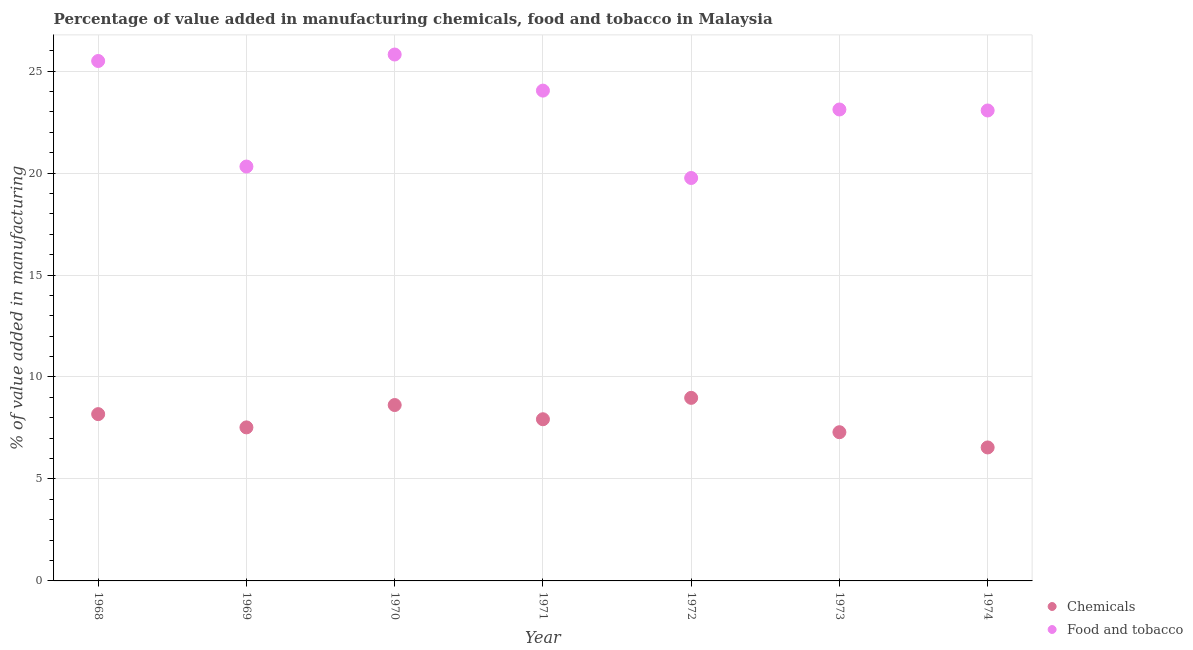Is the number of dotlines equal to the number of legend labels?
Provide a succinct answer. Yes. What is the value added by  manufacturing chemicals in 1968?
Give a very brief answer. 8.18. Across all years, what is the maximum value added by  manufacturing chemicals?
Your answer should be very brief. 8.98. Across all years, what is the minimum value added by  manufacturing chemicals?
Offer a terse response. 6.54. In which year was the value added by manufacturing food and tobacco maximum?
Offer a terse response. 1970. What is the total value added by manufacturing food and tobacco in the graph?
Keep it short and to the point. 161.61. What is the difference between the value added by manufacturing food and tobacco in 1971 and that in 1974?
Ensure brevity in your answer.  0.97. What is the difference between the value added by manufacturing food and tobacco in 1969 and the value added by  manufacturing chemicals in 1968?
Give a very brief answer. 12.14. What is the average value added by  manufacturing chemicals per year?
Provide a succinct answer. 7.87. In the year 1972, what is the difference between the value added by manufacturing food and tobacco and value added by  manufacturing chemicals?
Offer a terse response. 10.78. In how many years, is the value added by manufacturing food and tobacco greater than 25 %?
Your answer should be compact. 2. What is the ratio of the value added by manufacturing food and tobacco in 1971 to that in 1972?
Your answer should be compact. 1.22. What is the difference between the highest and the second highest value added by manufacturing food and tobacco?
Provide a succinct answer. 0.32. What is the difference between the highest and the lowest value added by manufacturing food and tobacco?
Offer a terse response. 6.05. Is the value added by manufacturing food and tobacco strictly greater than the value added by  manufacturing chemicals over the years?
Ensure brevity in your answer.  Yes. Is the value added by  manufacturing chemicals strictly less than the value added by manufacturing food and tobacco over the years?
Make the answer very short. Yes. How many dotlines are there?
Your answer should be very brief. 2. How many years are there in the graph?
Ensure brevity in your answer.  7. What is the difference between two consecutive major ticks on the Y-axis?
Make the answer very short. 5. Are the values on the major ticks of Y-axis written in scientific E-notation?
Your answer should be very brief. No. What is the title of the graph?
Your response must be concise. Percentage of value added in manufacturing chemicals, food and tobacco in Malaysia. What is the label or title of the Y-axis?
Provide a short and direct response. % of value added in manufacturing. What is the % of value added in manufacturing in Chemicals in 1968?
Make the answer very short. 8.18. What is the % of value added in manufacturing of Food and tobacco in 1968?
Offer a terse response. 25.49. What is the % of value added in manufacturing in Chemicals in 1969?
Ensure brevity in your answer.  7.53. What is the % of value added in manufacturing of Food and tobacco in 1969?
Your answer should be very brief. 20.32. What is the % of value added in manufacturing in Chemicals in 1970?
Offer a very short reply. 8.62. What is the % of value added in manufacturing in Food and tobacco in 1970?
Make the answer very short. 25.81. What is the % of value added in manufacturing in Chemicals in 1971?
Provide a succinct answer. 7.93. What is the % of value added in manufacturing of Food and tobacco in 1971?
Make the answer very short. 24.04. What is the % of value added in manufacturing in Chemicals in 1972?
Give a very brief answer. 8.98. What is the % of value added in manufacturing of Food and tobacco in 1972?
Provide a succinct answer. 19.76. What is the % of value added in manufacturing in Chemicals in 1973?
Ensure brevity in your answer.  7.29. What is the % of value added in manufacturing in Food and tobacco in 1973?
Your answer should be compact. 23.12. What is the % of value added in manufacturing in Chemicals in 1974?
Ensure brevity in your answer.  6.54. What is the % of value added in manufacturing in Food and tobacco in 1974?
Keep it short and to the point. 23.07. Across all years, what is the maximum % of value added in manufacturing of Chemicals?
Your answer should be very brief. 8.98. Across all years, what is the maximum % of value added in manufacturing in Food and tobacco?
Provide a succinct answer. 25.81. Across all years, what is the minimum % of value added in manufacturing in Chemicals?
Your answer should be very brief. 6.54. Across all years, what is the minimum % of value added in manufacturing in Food and tobacco?
Offer a terse response. 19.76. What is the total % of value added in manufacturing in Chemicals in the graph?
Make the answer very short. 55.07. What is the total % of value added in manufacturing in Food and tobacco in the graph?
Offer a very short reply. 161.61. What is the difference between the % of value added in manufacturing of Chemicals in 1968 and that in 1969?
Offer a very short reply. 0.65. What is the difference between the % of value added in manufacturing in Food and tobacco in 1968 and that in 1969?
Offer a terse response. 5.18. What is the difference between the % of value added in manufacturing of Chemicals in 1968 and that in 1970?
Your answer should be very brief. -0.45. What is the difference between the % of value added in manufacturing of Food and tobacco in 1968 and that in 1970?
Your response must be concise. -0.32. What is the difference between the % of value added in manufacturing in Chemicals in 1968 and that in 1971?
Offer a terse response. 0.25. What is the difference between the % of value added in manufacturing of Food and tobacco in 1968 and that in 1971?
Provide a succinct answer. 1.45. What is the difference between the % of value added in manufacturing in Chemicals in 1968 and that in 1972?
Offer a very short reply. -0.8. What is the difference between the % of value added in manufacturing of Food and tobacco in 1968 and that in 1972?
Your answer should be very brief. 5.74. What is the difference between the % of value added in manufacturing of Chemicals in 1968 and that in 1973?
Give a very brief answer. 0.89. What is the difference between the % of value added in manufacturing in Food and tobacco in 1968 and that in 1973?
Your response must be concise. 2.38. What is the difference between the % of value added in manufacturing in Chemicals in 1968 and that in 1974?
Make the answer very short. 1.63. What is the difference between the % of value added in manufacturing of Food and tobacco in 1968 and that in 1974?
Provide a succinct answer. 2.43. What is the difference between the % of value added in manufacturing in Chemicals in 1969 and that in 1970?
Give a very brief answer. -1.1. What is the difference between the % of value added in manufacturing in Food and tobacco in 1969 and that in 1970?
Provide a short and direct response. -5.49. What is the difference between the % of value added in manufacturing in Chemicals in 1969 and that in 1971?
Offer a very short reply. -0.4. What is the difference between the % of value added in manufacturing in Food and tobacco in 1969 and that in 1971?
Make the answer very short. -3.72. What is the difference between the % of value added in manufacturing of Chemicals in 1969 and that in 1972?
Offer a very short reply. -1.45. What is the difference between the % of value added in manufacturing of Food and tobacco in 1969 and that in 1972?
Offer a terse response. 0.56. What is the difference between the % of value added in manufacturing of Chemicals in 1969 and that in 1973?
Your response must be concise. 0.24. What is the difference between the % of value added in manufacturing of Food and tobacco in 1969 and that in 1973?
Give a very brief answer. -2.8. What is the difference between the % of value added in manufacturing of Chemicals in 1969 and that in 1974?
Make the answer very short. 0.98. What is the difference between the % of value added in manufacturing in Food and tobacco in 1969 and that in 1974?
Your response must be concise. -2.75. What is the difference between the % of value added in manufacturing of Chemicals in 1970 and that in 1971?
Your response must be concise. 0.7. What is the difference between the % of value added in manufacturing in Food and tobacco in 1970 and that in 1971?
Ensure brevity in your answer.  1.77. What is the difference between the % of value added in manufacturing in Chemicals in 1970 and that in 1972?
Offer a terse response. -0.35. What is the difference between the % of value added in manufacturing in Food and tobacco in 1970 and that in 1972?
Offer a very short reply. 6.05. What is the difference between the % of value added in manufacturing in Chemicals in 1970 and that in 1973?
Your answer should be very brief. 1.33. What is the difference between the % of value added in manufacturing in Food and tobacco in 1970 and that in 1973?
Your answer should be compact. 2.7. What is the difference between the % of value added in manufacturing of Chemicals in 1970 and that in 1974?
Give a very brief answer. 2.08. What is the difference between the % of value added in manufacturing of Food and tobacco in 1970 and that in 1974?
Your answer should be compact. 2.74. What is the difference between the % of value added in manufacturing of Chemicals in 1971 and that in 1972?
Ensure brevity in your answer.  -1.05. What is the difference between the % of value added in manufacturing in Food and tobacco in 1971 and that in 1972?
Make the answer very short. 4.28. What is the difference between the % of value added in manufacturing of Chemicals in 1971 and that in 1973?
Offer a very short reply. 0.64. What is the difference between the % of value added in manufacturing of Food and tobacco in 1971 and that in 1973?
Ensure brevity in your answer.  0.93. What is the difference between the % of value added in manufacturing in Chemicals in 1971 and that in 1974?
Provide a succinct answer. 1.38. What is the difference between the % of value added in manufacturing in Food and tobacco in 1971 and that in 1974?
Make the answer very short. 0.97. What is the difference between the % of value added in manufacturing of Chemicals in 1972 and that in 1973?
Make the answer very short. 1.69. What is the difference between the % of value added in manufacturing of Food and tobacco in 1972 and that in 1973?
Offer a terse response. -3.36. What is the difference between the % of value added in manufacturing in Chemicals in 1972 and that in 1974?
Your answer should be compact. 2.43. What is the difference between the % of value added in manufacturing of Food and tobacco in 1972 and that in 1974?
Give a very brief answer. -3.31. What is the difference between the % of value added in manufacturing of Chemicals in 1973 and that in 1974?
Offer a terse response. 0.75. What is the difference between the % of value added in manufacturing in Food and tobacco in 1973 and that in 1974?
Provide a short and direct response. 0.05. What is the difference between the % of value added in manufacturing in Chemicals in 1968 and the % of value added in manufacturing in Food and tobacco in 1969?
Your answer should be very brief. -12.14. What is the difference between the % of value added in manufacturing of Chemicals in 1968 and the % of value added in manufacturing of Food and tobacco in 1970?
Offer a terse response. -17.63. What is the difference between the % of value added in manufacturing in Chemicals in 1968 and the % of value added in manufacturing in Food and tobacco in 1971?
Give a very brief answer. -15.86. What is the difference between the % of value added in manufacturing of Chemicals in 1968 and the % of value added in manufacturing of Food and tobacco in 1972?
Ensure brevity in your answer.  -11.58. What is the difference between the % of value added in manufacturing of Chemicals in 1968 and the % of value added in manufacturing of Food and tobacco in 1973?
Provide a succinct answer. -14.94. What is the difference between the % of value added in manufacturing in Chemicals in 1968 and the % of value added in manufacturing in Food and tobacco in 1974?
Provide a succinct answer. -14.89. What is the difference between the % of value added in manufacturing in Chemicals in 1969 and the % of value added in manufacturing in Food and tobacco in 1970?
Give a very brief answer. -18.28. What is the difference between the % of value added in manufacturing of Chemicals in 1969 and the % of value added in manufacturing of Food and tobacco in 1971?
Offer a very short reply. -16.51. What is the difference between the % of value added in manufacturing of Chemicals in 1969 and the % of value added in manufacturing of Food and tobacco in 1972?
Provide a short and direct response. -12.23. What is the difference between the % of value added in manufacturing in Chemicals in 1969 and the % of value added in manufacturing in Food and tobacco in 1973?
Give a very brief answer. -15.59. What is the difference between the % of value added in manufacturing of Chemicals in 1969 and the % of value added in manufacturing of Food and tobacco in 1974?
Offer a very short reply. -15.54. What is the difference between the % of value added in manufacturing of Chemicals in 1970 and the % of value added in manufacturing of Food and tobacco in 1971?
Provide a succinct answer. -15.42. What is the difference between the % of value added in manufacturing in Chemicals in 1970 and the % of value added in manufacturing in Food and tobacco in 1972?
Provide a succinct answer. -11.13. What is the difference between the % of value added in manufacturing in Chemicals in 1970 and the % of value added in manufacturing in Food and tobacco in 1973?
Provide a short and direct response. -14.49. What is the difference between the % of value added in manufacturing of Chemicals in 1970 and the % of value added in manufacturing of Food and tobacco in 1974?
Make the answer very short. -14.44. What is the difference between the % of value added in manufacturing in Chemicals in 1971 and the % of value added in manufacturing in Food and tobacco in 1972?
Provide a succinct answer. -11.83. What is the difference between the % of value added in manufacturing of Chemicals in 1971 and the % of value added in manufacturing of Food and tobacco in 1973?
Your answer should be compact. -15.19. What is the difference between the % of value added in manufacturing in Chemicals in 1971 and the % of value added in manufacturing in Food and tobacco in 1974?
Make the answer very short. -15.14. What is the difference between the % of value added in manufacturing in Chemicals in 1972 and the % of value added in manufacturing in Food and tobacco in 1973?
Your answer should be very brief. -14.14. What is the difference between the % of value added in manufacturing of Chemicals in 1972 and the % of value added in manufacturing of Food and tobacco in 1974?
Offer a terse response. -14.09. What is the difference between the % of value added in manufacturing of Chemicals in 1973 and the % of value added in manufacturing of Food and tobacco in 1974?
Offer a terse response. -15.78. What is the average % of value added in manufacturing of Chemicals per year?
Provide a succinct answer. 7.87. What is the average % of value added in manufacturing in Food and tobacco per year?
Offer a very short reply. 23.09. In the year 1968, what is the difference between the % of value added in manufacturing of Chemicals and % of value added in manufacturing of Food and tobacco?
Give a very brief answer. -17.32. In the year 1969, what is the difference between the % of value added in manufacturing of Chemicals and % of value added in manufacturing of Food and tobacco?
Offer a very short reply. -12.79. In the year 1970, what is the difference between the % of value added in manufacturing of Chemicals and % of value added in manufacturing of Food and tobacco?
Your answer should be very brief. -17.19. In the year 1971, what is the difference between the % of value added in manufacturing in Chemicals and % of value added in manufacturing in Food and tobacco?
Offer a very short reply. -16.11. In the year 1972, what is the difference between the % of value added in manufacturing in Chemicals and % of value added in manufacturing in Food and tobacco?
Keep it short and to the point. -10.78. In the year 1973, what is the difference between the % of value added in manufacturing in Chemicals and % of value added in manufacturing in Food and tobacco?
Offer a very short reply. -15.83. In the year 1974, what is the difference between the % of value added in manufacturing in Chemicals and % of value added in manufacturing in Food and tobacco?
Make the answer very short. -16.52. What is the ratio of the % of value added in manufacturing in Chemicals in 1968 to that in 1969?
Provide a short and direct response. 1.09. What is the ratio of the % of value added in manufacturing in Food and tobacco in 1968 to that in 1969?
Keep it short and to the point. 1.25. What is the ratio of the % of value added in manufacturing of Chemicals in 1968 to that in 1970?
Your answer should be very brief. 0.95. What is the ratio of the % of value added in manufacturing in Chemicals in 1968 to that in 1971?
Provide a short and direct response. 1.03. What is the ratio of the % of value added in manufacturing of Food and tobacco in 1968 to that in 1971?
Keep it short and to the point. 1.06. What is the ratio of the % of value added in manufacturing in Chemicals in 1968 to that in 1972?
Ensure brevity in your answer.  0.91. What is the ratio of the % of value added in manufacturing in Food and tobacco in 1968 to that in 1972?
Your answer should be very brief. 1.29. What is the ratio of the % of value added in manufacturing of Chemicals in 1968 to that in 1973?
Your answer should be compact. 1.12. What is the ratio of the % of value added in manufacturing in Food and tobacco in 1968 to that in 1973?
Offer a very short reply. 1.1. What is the ratio of the % of value added in manufacturing of Chemicals in 1968 to that in 1974?
Provide a succinct answer. 1.25. What is the ratio of the % of value added in manufacturing of Food and tobacco in 1968 to that in 1974?
Your response must be concise. 1.11. What is the ratio of the % of value added in manufacturing in Chemicals in 1969 to that in 1970?
Offer a very short reply. 0.87. What is the ratio of the % of value added in manufacturing in Food and tobacco in 1969 to that in 1970?
Offer a very short reply. 0.79. What is the ratio of the % of value added in manufacturing of Chemicals in 1969 to that in 1971?
Ensure brevity in your answer.  0.95. What is the ratio of the % of value added in manufacturing in Food and tobacco in 1969 to that in 1971?
Provide a short and direct response. 0.85. What is the ratio of the % of value added in manufacturing in Chemicals in 1969 to that in 1972?
Provide a succinct answer. 0.84. What is the ratio of the % of value added in manufacturing in Food and tobacco in 1969 to that in 1972?
Provide a succinct answer. 1.03. What is the ratio of the % of value added in manufacturing in Chemicals in 1969 to that in 1973?
Make the answer very short. 1.03. What is the ratio of the % of value added in manufacturing of Food and tobacco in 1969 to that in 1973?
Provide a short and direct response. 0.88. What is the ratio of the % of value added in manufacturing of Chemicals in 1969 to that in 1974?
Your answer should be compact. 1.15. What is the ratio of the % of value added in manufacturing of Food and tobacco in 1969 to that in 1974?
Offer a very short reply. 0.88. What is the ratio of the % of value added in manufacturing of Chemicals in 1970 to that in 1971?
Give a very brief answer. 1.09. What is the ratio of the % of value added in manufacturing of Food and tobacco in 1970 to that in 1971?
Offer a terse response. 1.07. What is the ratio of the % of value added in manufacturing in Chemicals in 1970 to that in 1972?
Give a very brief answer. 0.96. What is the ratio of the % of value added in manufacturing of Food and tobacco in 1970 to that in 1972?
Offer a terse response. 1.31. What is the ratio of the % of value added in manufacturing in Chemicals in 1970 to that in 1973?
Make the answer very short. 1.18. What is the ratio of the % of value added in manufacturing of Food and tobacco in 1970 to that in 1973?
Make the answer very short. 1.12. What is the ratio of the % of value added in manufacturing in Chemicals in 1970 to that in 1974?
Your answer should be compact. 1.32. What is the ratio of the % of value added in manufacturing of Food and tobacco in 1970 to that in 1974?
Give a very brief answer. 1.12. What is the ratio of the % of value added in manufacturing of Chemicals in 1971 to that in 1972?
Keep it short and to the point. 0.88. What is the ratio of the % of value added in manufacturing in Food and tobacco in 1971 to that in 1972?
Provide a short and direct response. 1.22. What is the ratio of the % of value added in manufacturing in Chemicals in 1971 to that in 1973?
Your response must be concise. 1.09. What is the ratio of the % of value added in manufacturing of Food and tobacco in 1971 to that in 1973?
Offer a very short reply. 1.04. What is the ratio of the % of value added in manufacturing in Chemicals in 1971 to that in 1974?
Ensure brevity in your answer.  1.21. What is the ratio of the % of value added in manufacturing in Food and tobacco in 1971 to that in 1974?
Your answer should be compact. 1.04. What is the ratio of the % of value added in manufacturing of Chemicals in 1972 to that in 1973?
Ensure brevity in your answer.  1.23. What is the ratio of the % of value added in manufacturing in Food and tobacco in 1972 to that in 1973?
Make the answer very short. 0.85. What is the ratio of the % of value added in manufacturing in Chemicals in 1972 to that in 1974?
Your response must be concise. 1.37. What is the ratio of the % of value added in manufacturing of Food and tobacco in 1972 to that in 1974?
Keep it short and to the point. 0.86. What is the ratio of the % of value added in manufacturing in Chemicals in 1973 to that in 1974?
Your answer should be very brief. 1.11. What is the difference between the highest and the second highest % of value added in manufacturing in Chemicals?
Your response must be concise. 0.35. What is the difference between the highest and the second highest % of value added in manufacturing of Food and tobacco?
Provide a short and direct response. 0.32. What is the difference between the highest and the lowest % of value added in manufacturing of Chemicals?
Offer a terse response. 2.43. What is the difference between the highest and the lowest % of value added in manufacturing of Food and tobacco?
Ensure brevity in your answer.  6.05. 